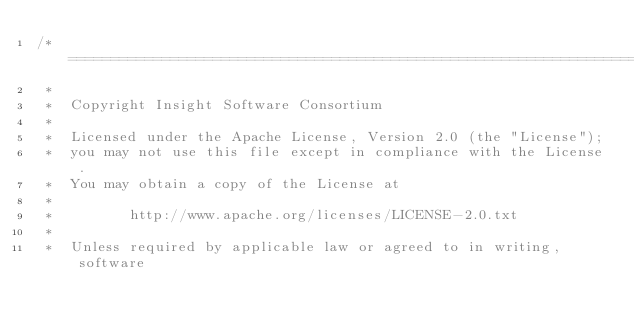<code> <loc_0><loc_0><loc_500><loc_500><_C++_>/*=========================================================================
 *
 *  Copyright Insight Software Consortium
 *
 *  Licensed under the Apache License, Version 2.0 (the "License");
 *  you may not use this file except in compliance with the License.
 *  You may obtain a copy of the License at
 *
 *         http://www.apache.org/licenses/LICENSE-2.0.txt
 *
 *  Unless required by applicable law or agreed to in writing, software</code> 